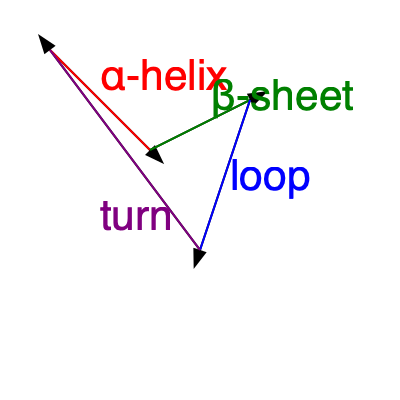Imagine rotating the given protein structure 90 degrees clockwise around the vertical axis. Which secondary structure element would be closest to you after the rotation? To solve this problem, we need to visualize the 3D rotation of the protein structure:

1. The current view shows a simplified 2D representation of a protein structure with four main secondary structure elements: α-helix (red), β-sheet (green), loop (blue), and turn (purple).

2. We need to mentally rotate this structure 90 degrees clockwise around the vertical axis. This means we're essentially looking at the structure from the right side of the current view.

3. Before rotation:
   - The α-helix (red) is on the left front.
   - The β-sheet (green) is on the right front.
   - The loop (blue) is on the right back.
   - The turn (purple) is on the left back.

4. After 90-degree clockwise rotation:
   - The α-helix (red) would move to the back.
   - The β-sheet (green) would become the closest, moving to the front.
   - The loop (blue) would move to the right side.
   - The turn (purple) would move to the left side.

5. Therefore, after the rotation, the β-sheet (green) would be closest to the viewer.
Answer: β-sheet 